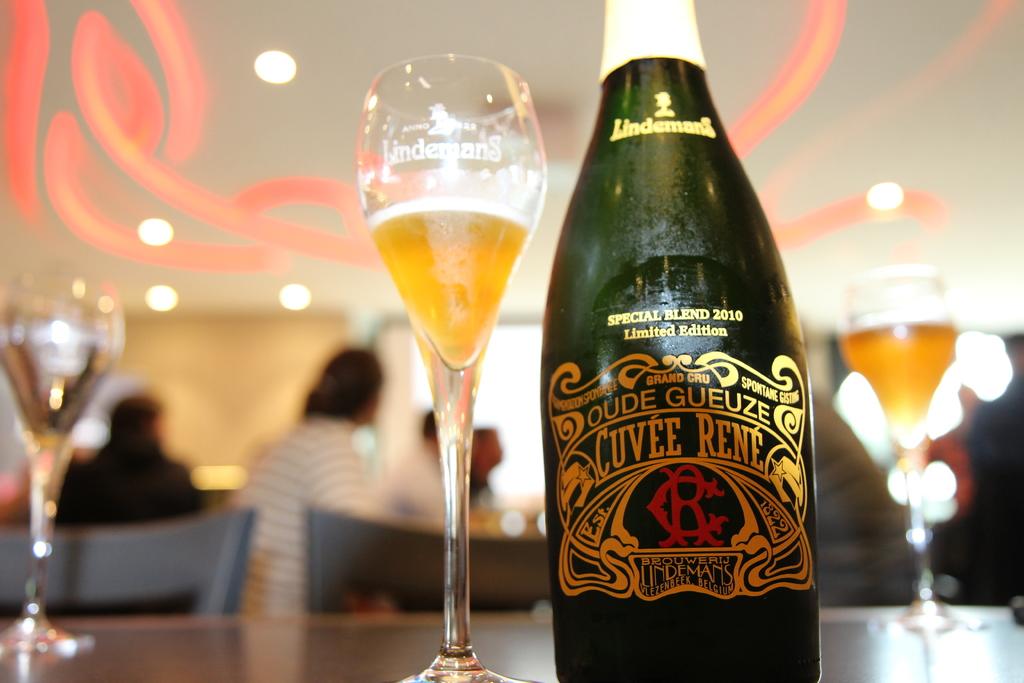What brand is on this bottle?
Offer a terse response. Cuvee rene. 